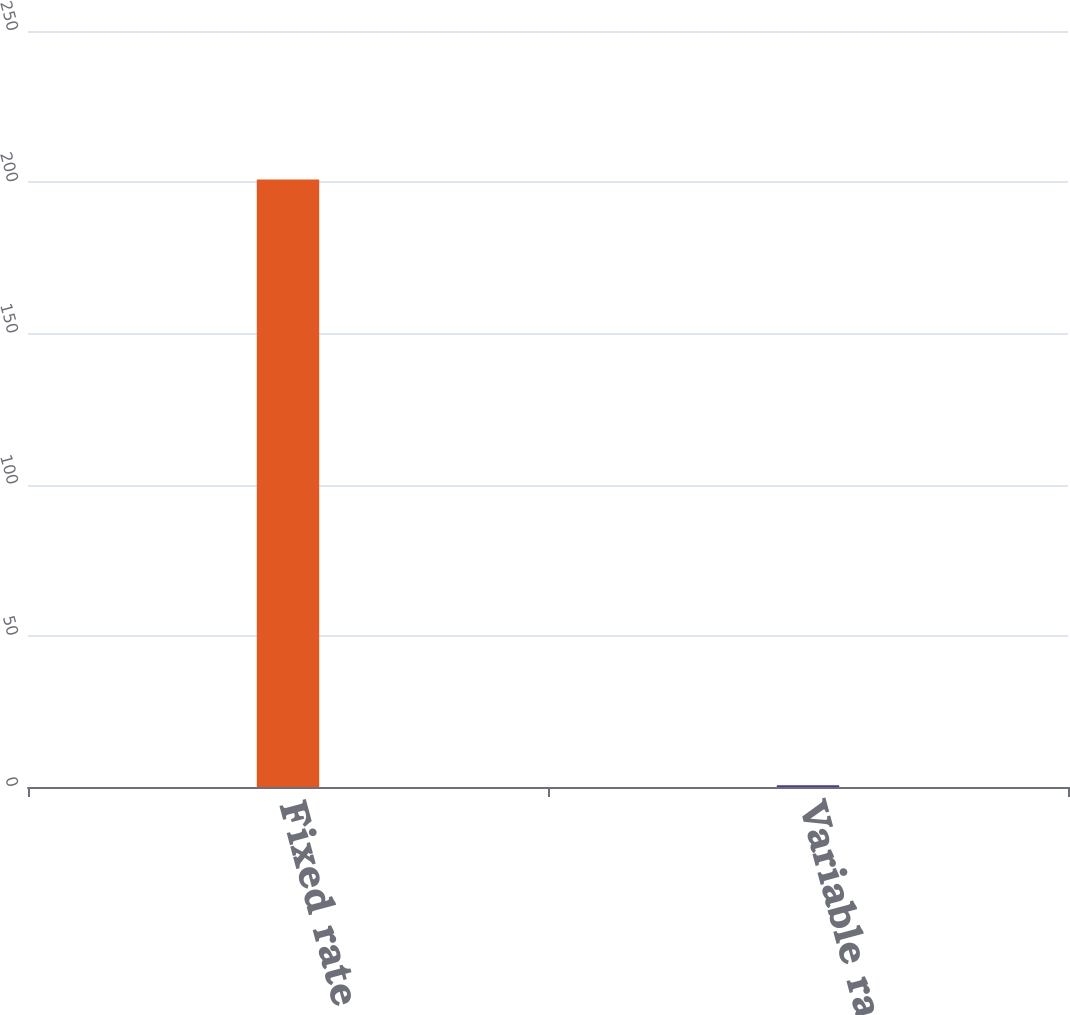Convert chart to OTSL. <chart><loc_0><loc_0><loc_500><loc_500><bar_chart><fcel>Fixed rate<fcel>Variable rate<nl><fcel>200.9<fcel>0.6<nl></chart> 